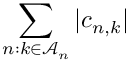<formula> <loc_0><loc_0><loc_500><loc_500>\sum _ { n \colon k \in \mathcal { A } _ { n } } | c _ { n , k } |</formula> 